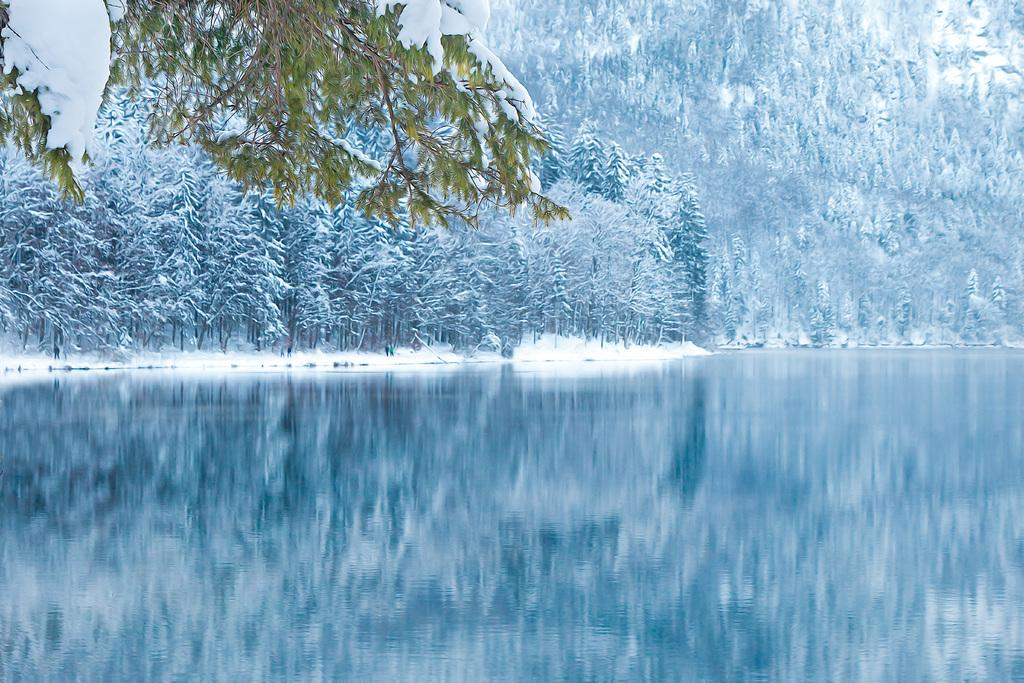What type of vegetation can be seen in the image? There are trees in the image. What is covering the trees in the image? The trees are covered with snow. What can be seen at the bottom of the image? There is water visible at the bottom of the image. What flavor of linen can be seen hanging from the trees in the image? There is no linen present in the image, and therefore no flavor can be associated with it. 